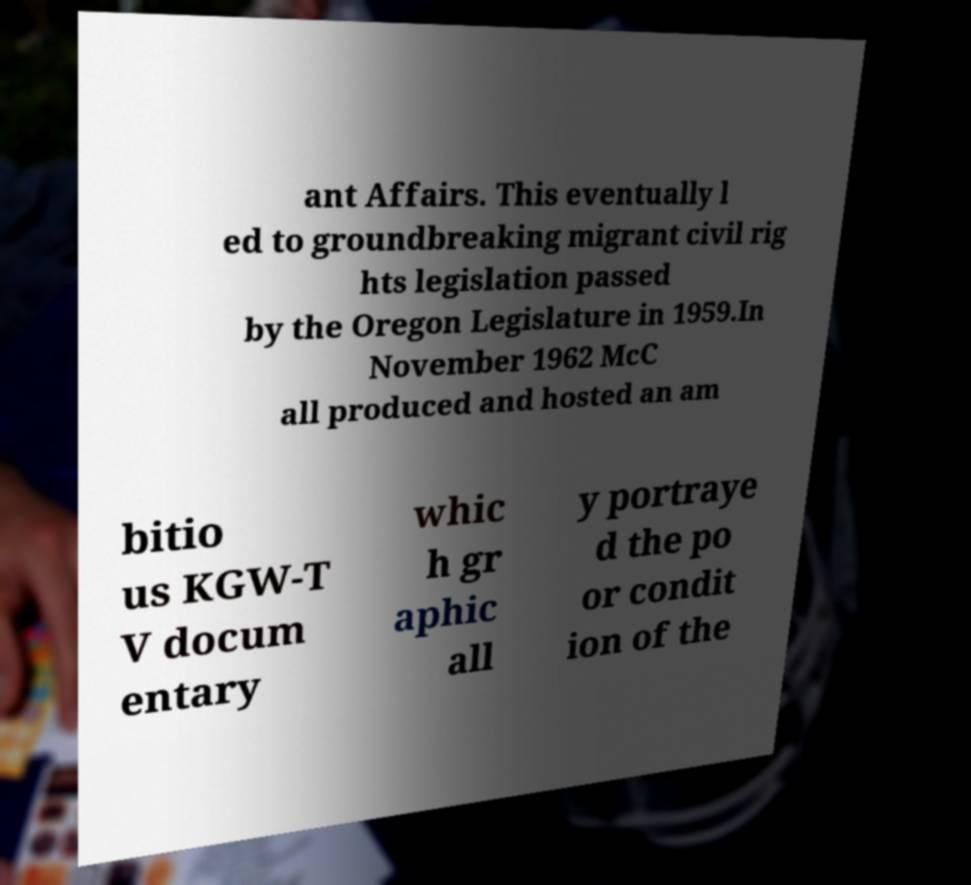I need the written content from this picture converted into text. Can you do that? ant Affairs. This eventually l ed to groundbreaking migrant civil rig hts legislation passed by the Oregon Legislature in 1959.In November 1962 McC all produced and hosted an am bitio us KGW-T V docum entary whic h gr aphic all y portraye d the po or condit ion of the 